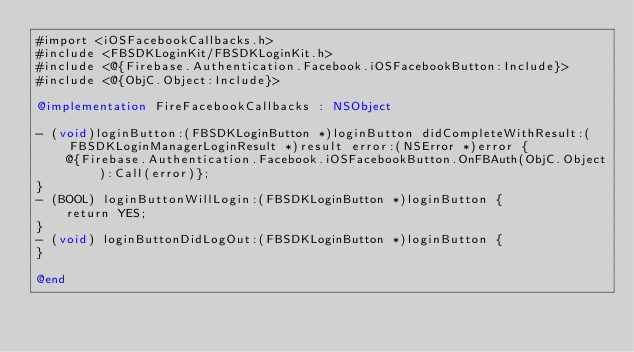<code> <loc_0><loc_0><loc_500><loc_500><_ObjectiveC_>#import <iOSFacebookCallbacks.h>
#include <FBSDKLoginKit/FBSDKLoginKit.h>
#include <@{Firebase.Authentication.Facebook.iOSFacebookButton:Include}>
#include <@{ObjC.Object:Include}>

@implementation FireFacebookCallbacks : NSObject

- (void)loginButton:(FBSDKLoginButton *)loginButton didCompleteWithResult:(FBSDKLoginManagerLoginResult *)result error:(NSError *)error {
    @{Firebase.Authentication.Facebook.iOSFacebookButton.OnFBAuth(ObjC.Object):Call(error)};
}
- (BOOL) loginButtonWillLogin:(FBSDKLoginButton *)loginButton {
    return YES;
}
- (void) loginButtonDidLogOut:(FBSDKLoginButton *)loginButton {
}

@end
</code> 